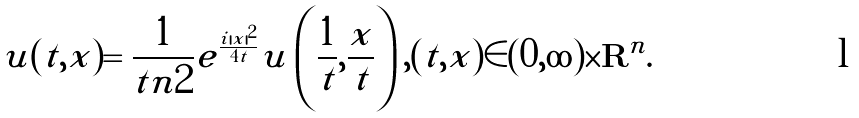<formula> <loc_0><loc_0><loc_500><loc_500>\tilde { u } ( t , x ) = \frac { 1 } { t ^ { } { n } 2 } e ^ { \frac { { i } | x | ^ { 2 } } { 4 t } } u \left ( \frac { 1 } { t } , \frac { x } { t } \right ) , ( t , x ) \in ( 0 , \infty ) \times { \mathbf R } ^ { n } .</formula> 